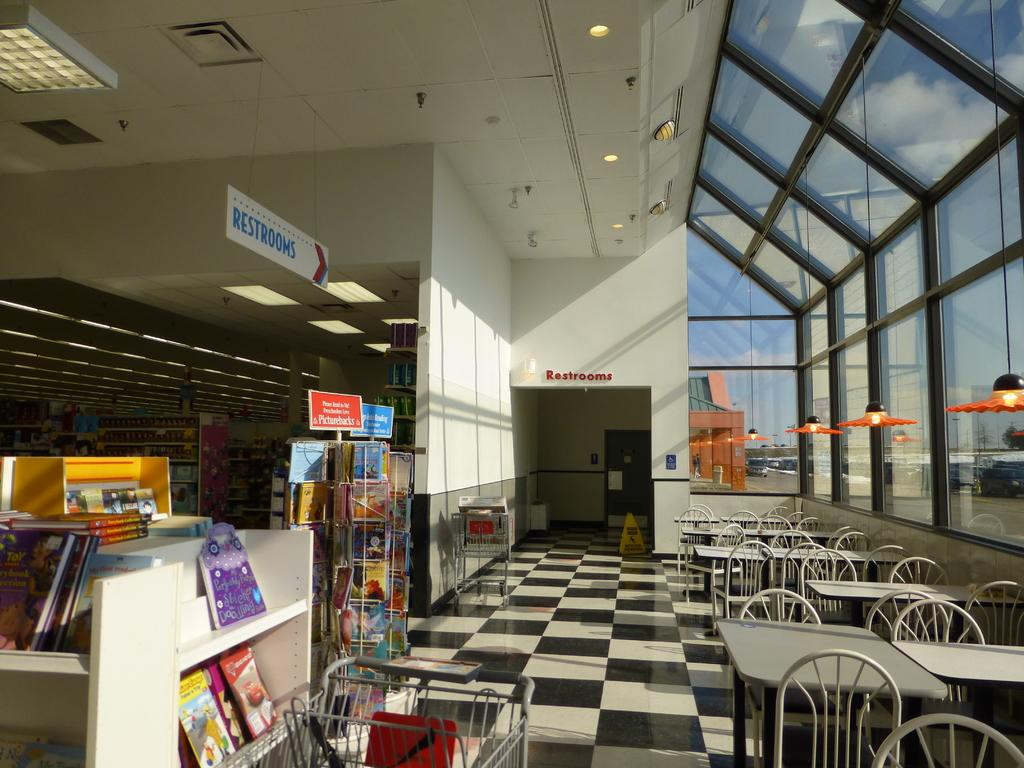<image>
Offer a succinct explanation of the picture presented. A sign pointing to the restrooms hangs from the ceiling of a store. 